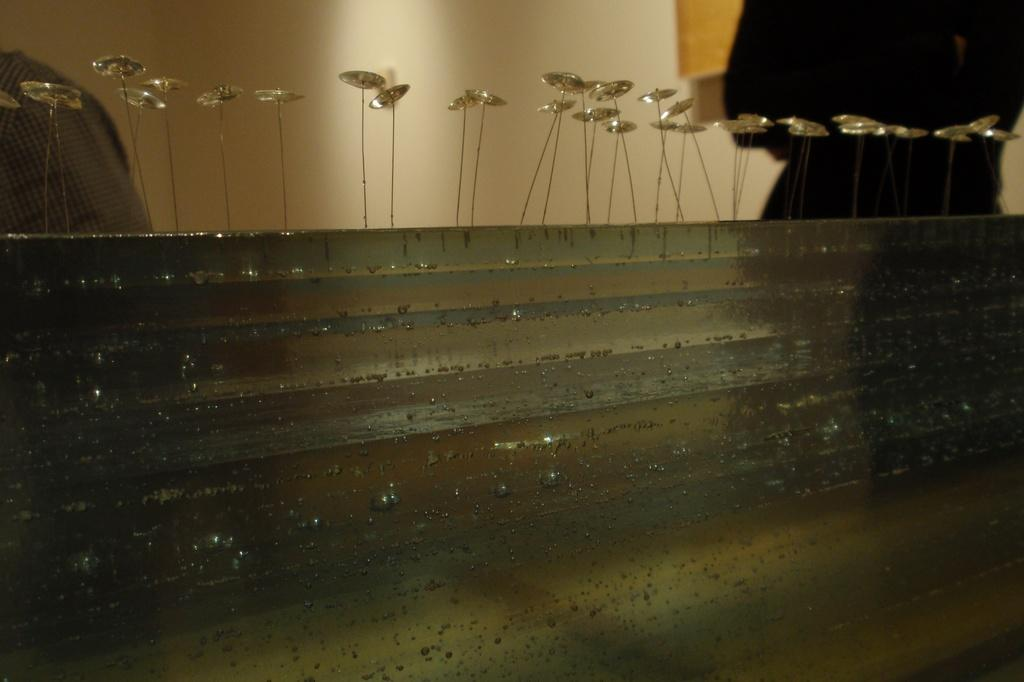What is on the wall that is visible in the image? There is a wall with decorative items in the image. Can you describe the setting in the background of the image? There are people and another wall in the background of the image. How many bottles are being held by the partner in the image? There is no partner or bottle present in the image. 